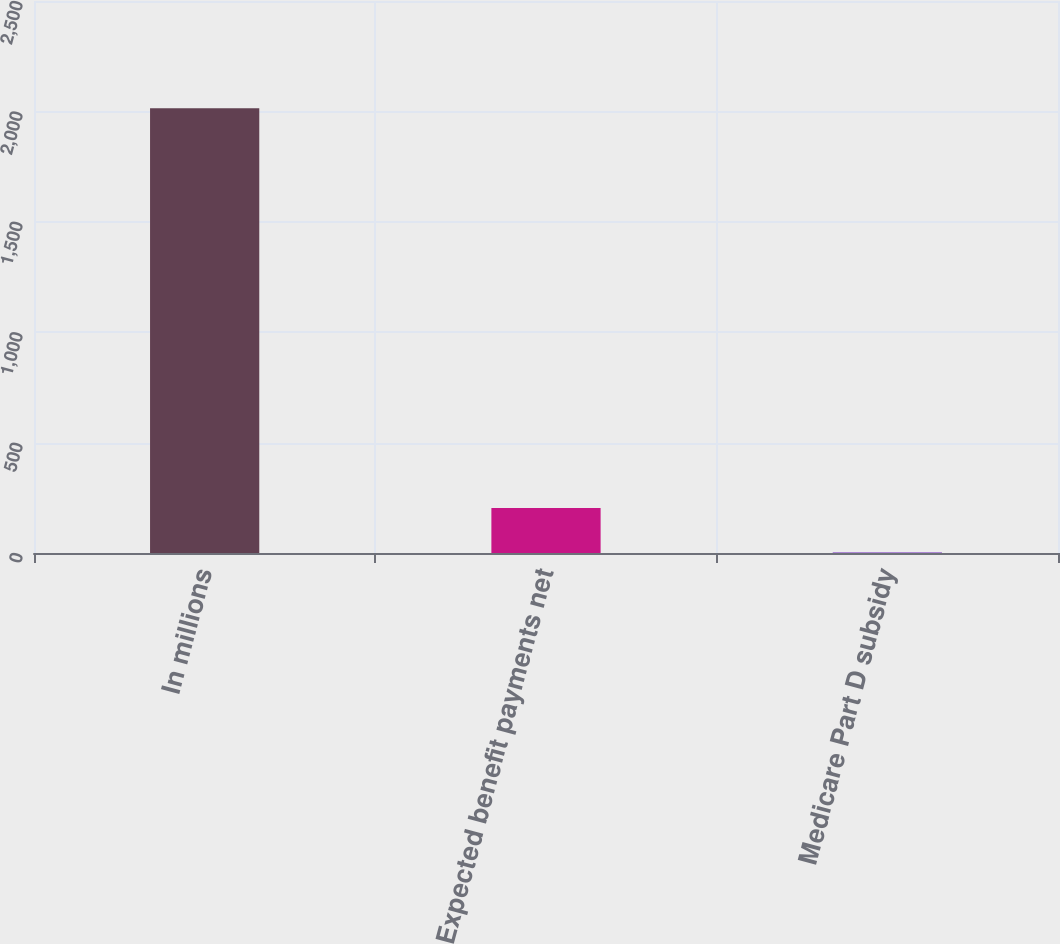Convert chart to OTSL. <chart><loc_0><loc_0><loc_500><loc_500><bar_chart><fcel>In millions<fcel>Expected benefit payments net<fcel>Medicare Part D subsidy<nl><fcel>2014<fcel>204.1<fcel>3<nl></chart> 